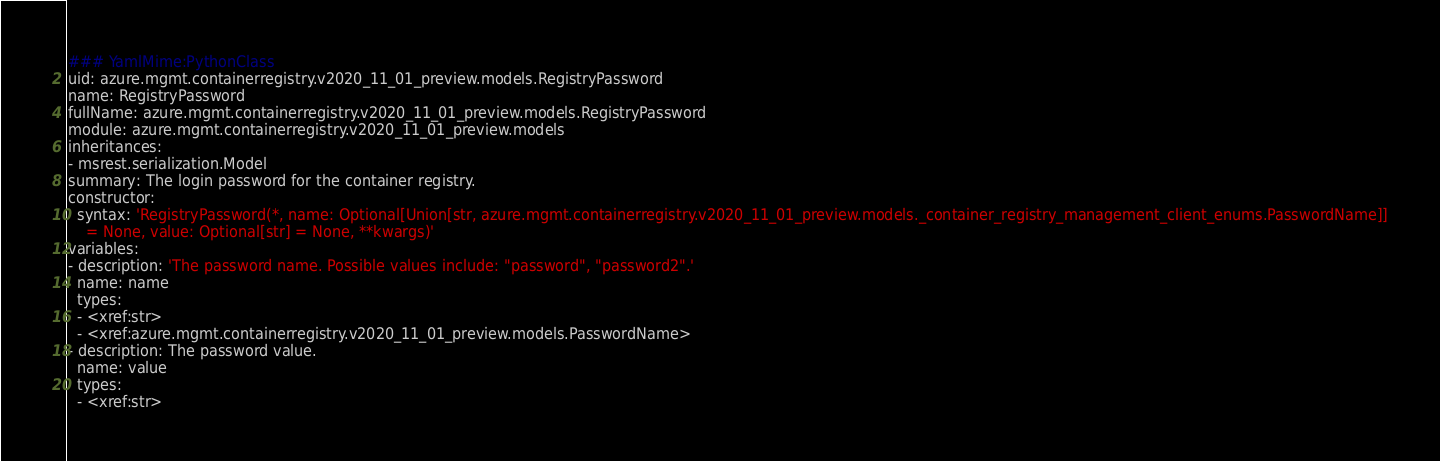<code> <loc_0><loc_0><loc_500><loc_500><_YAML_>### YamlMime:PythonClass
uid: azure.mgmt.containerregistry.v2020_11_01_preview.models.RegistryPassword
name: RegistryPassword
fullName: azure.mgmt.containerregistry.v2020_11_01_preview.models.RegistryPassword
module: azure.mgmt.containerregistry.v2020_11_01_preview.models
inheritances:
- msrest.serialization.Model
summary: The login password for the container registry.
constructor:
  syntax: 'RegistryPassword(*, name: Optional[Union[str, azure.mgmt.containerregistry.v2020_11_01_preview.models._container_registry_management_client_enums.PasswordName]]
    = None, value: Optional[str] = None, **kwargs)'
variables:
- description: 'The password name. Possible values include: "password", "password2".'
  name: name
  types:
  - <xref:str>
  - <xref:azure.mgmt.containerregistry.v2020_11_01_preview.models.PasswordName>
- description: The password value.
  name: value
  types:
  - <xref:str>
</code> 